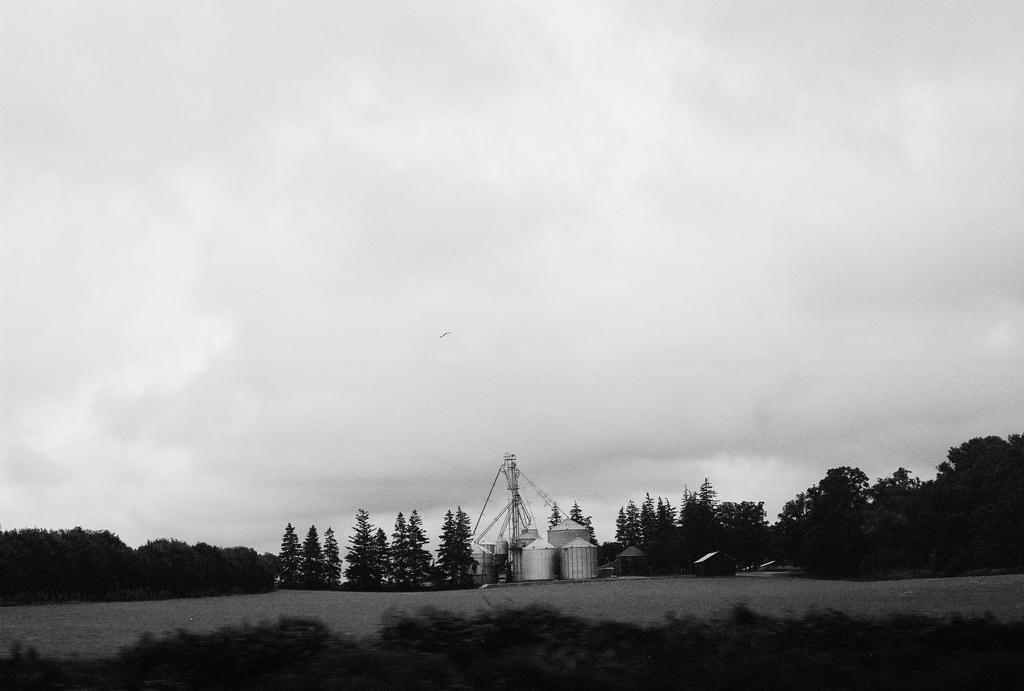What is the color scheme of the image? The image is black and white. What objects can be seen in the image? There are containers and poles in the image. What type of natural elements are present in the image? There are trees in the image. What can be seen in the background of the image? The sky is visible in the background of the image. How would you describe the clarity of the image? The bottom of the image is blurry. Can you tell me how many steps are visible in the image? There are no steps present in the image. What type of box is being used for driving in the image? There is no box or driving activity depicted in the image. 